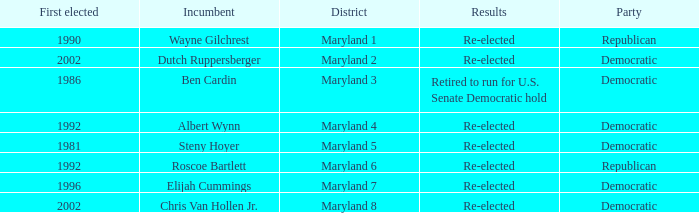What are the results of the incumbent who was first elected in 1996? Re-elected. 